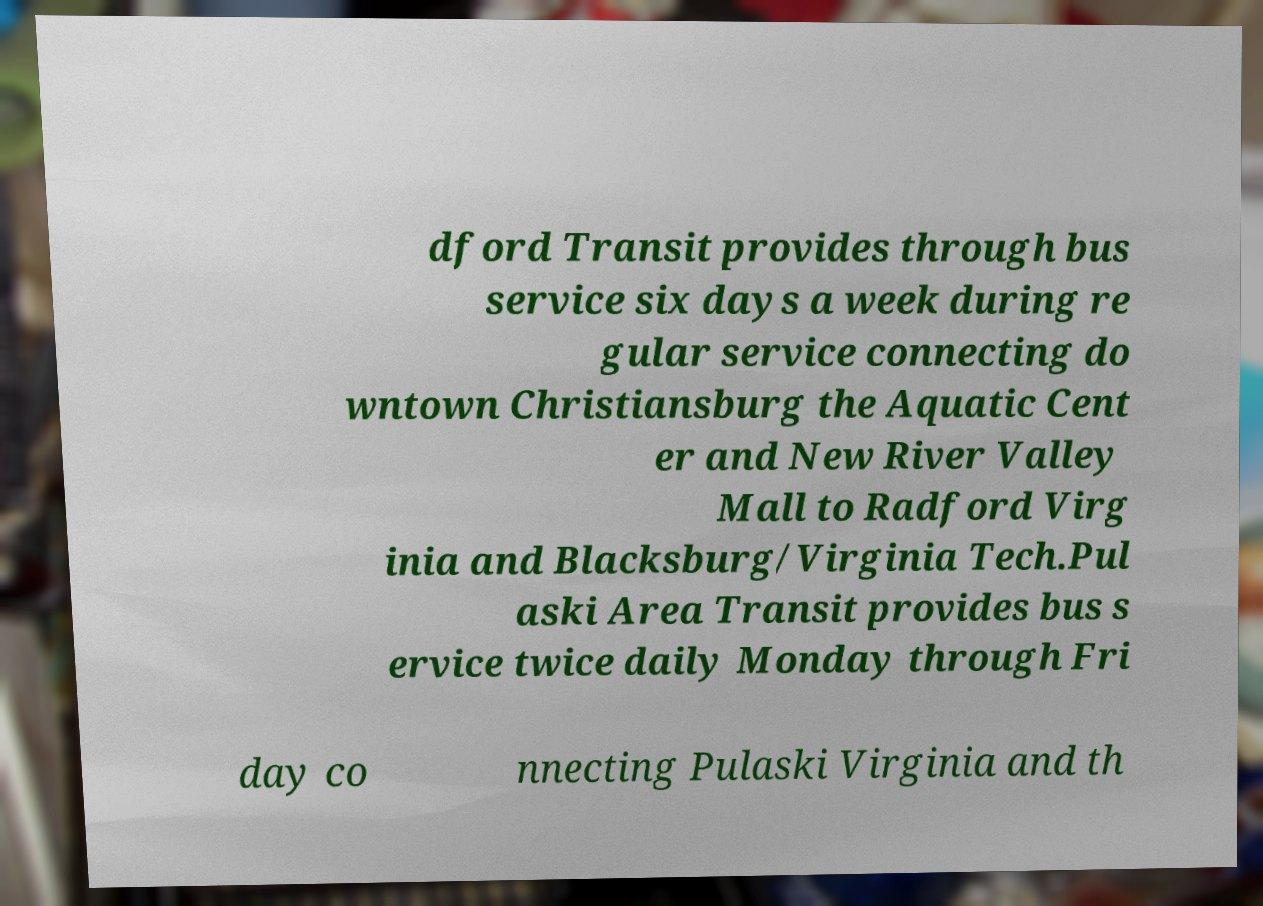Please read and relay the text visible in this image. What does it say? dford Transit provides through bus service six days a week during re gular service connecting do wntown Christiansburg the Aquatic Cent er and New River Valley Mall to Radford Virg inia and Blacksburg/Virginia Tech.Pul aski Area Transit provides bus s ervice twice daily Monday through Fri day co nnecting Pulaski Virginia and th 